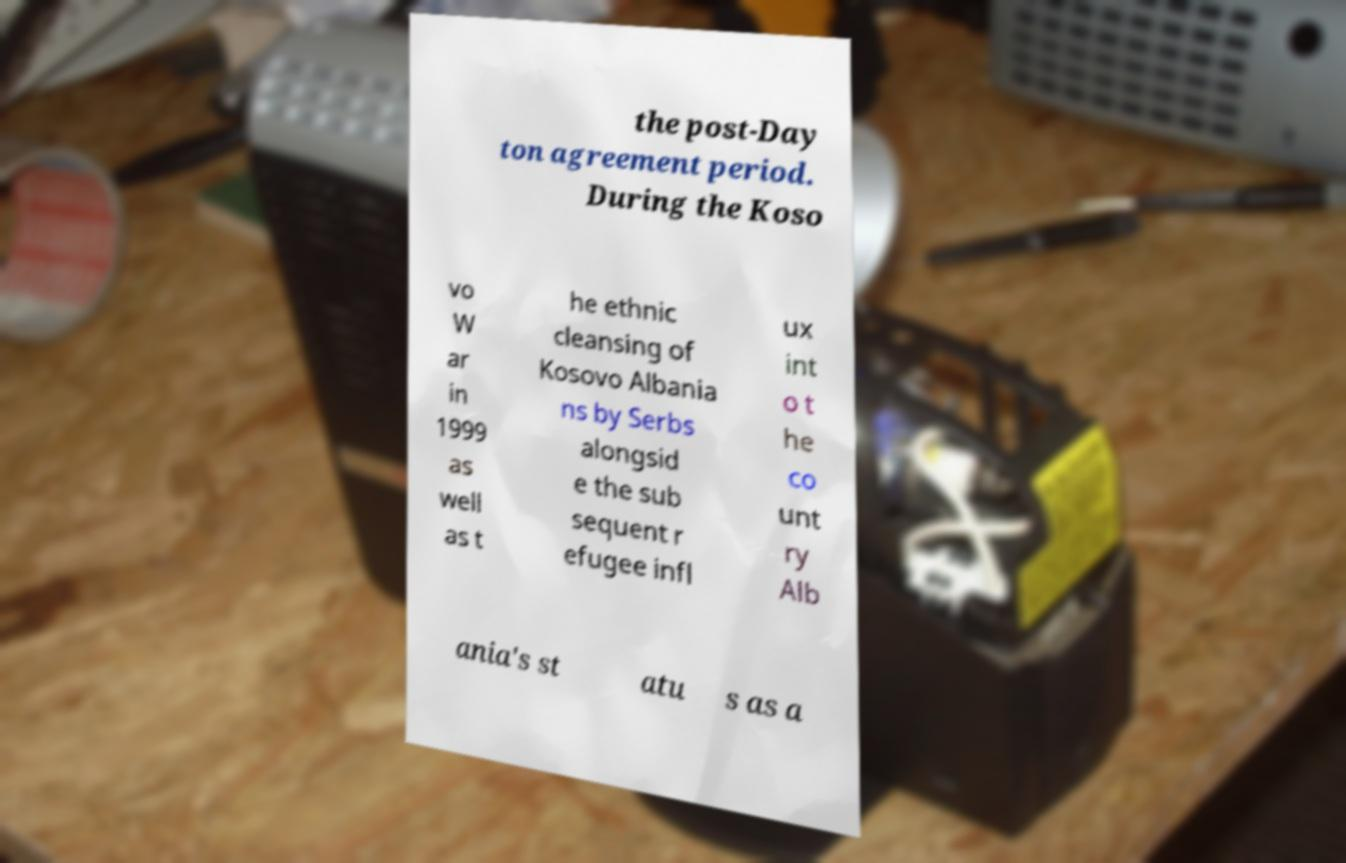What messages or text are displayed in this image? I need them in a readable, typed format. the post-Day ton agreement period. During the Koso vo W ar in 1999 as well as t he ethnic cleansing of Kosovo Albania ns by Serbs alongsid e the sub sequent r efugee infl ux int o t he co unt ry Alb ania's st atu s as a 